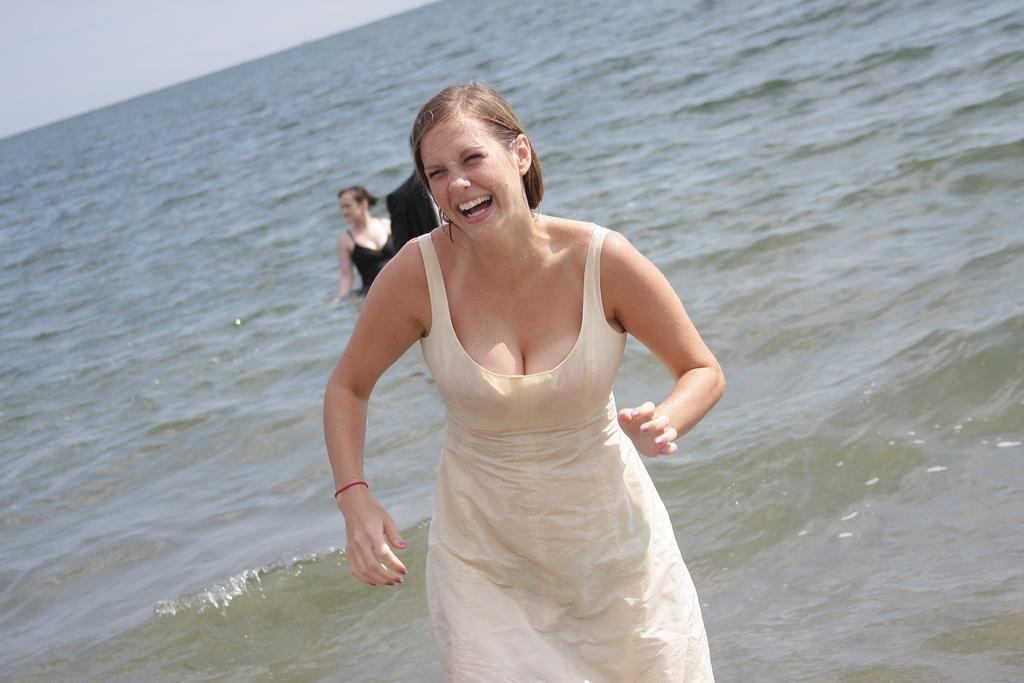How many people are in the image? There are people in the image, but the exact number is not specified. What is visible in the background of the image? Water is visible in the image. Can you describe the expression of one of the people in the image? Yes, a person is smiling in the front of the image. What type of notebook is being used by the person in the image? There is no mention of a notebook in the image, so it cannot be determined if someone is using one. 